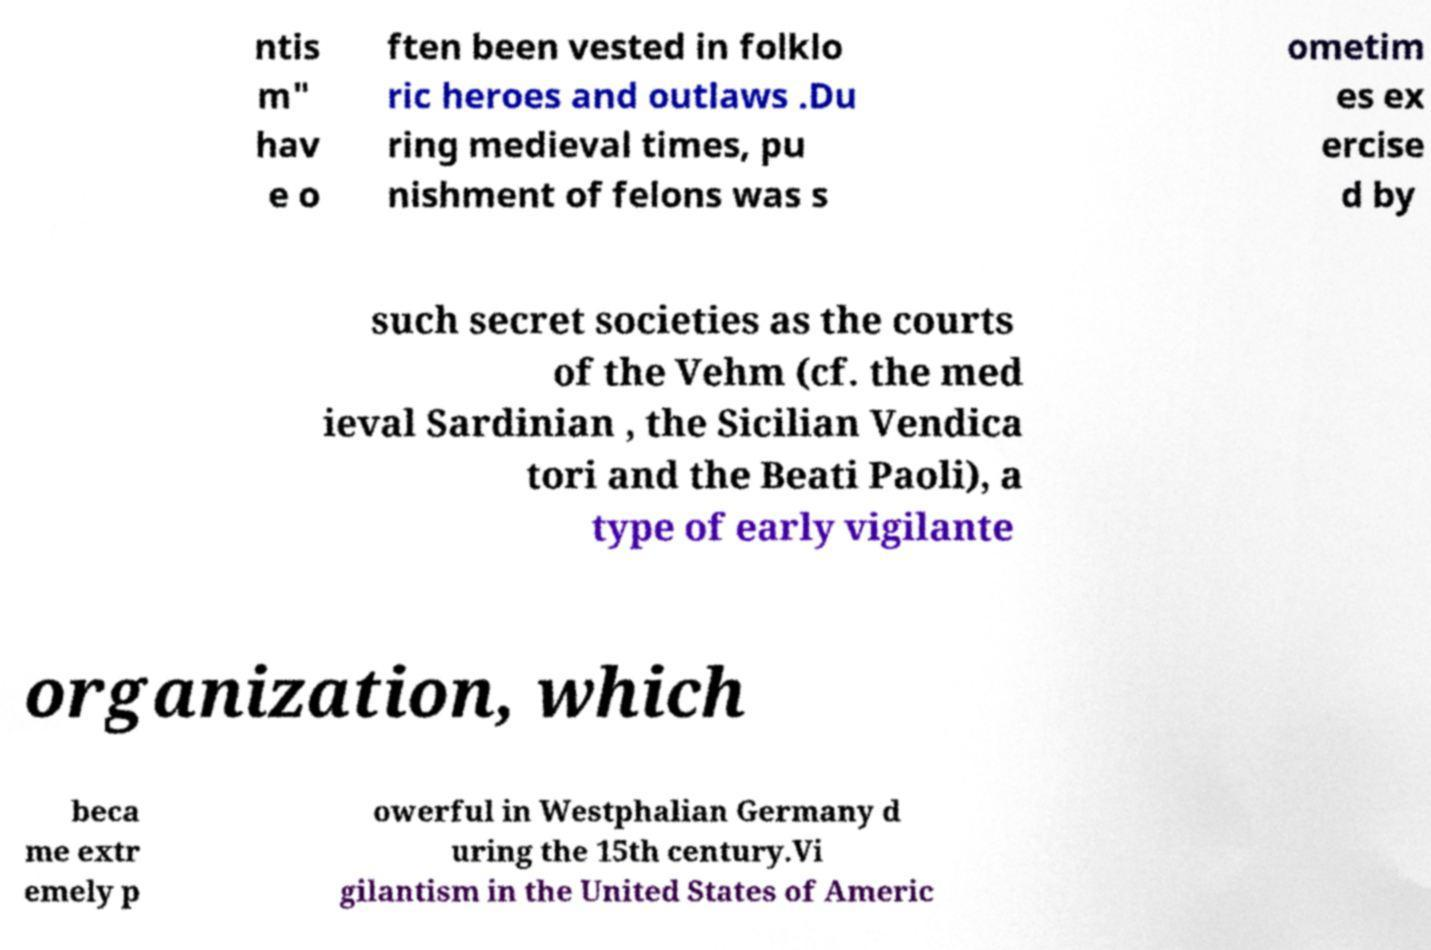For documentation purposes, I need the text within this image transcribed. Could you provide that? ntis m" hav e o ften been vested in folklo ric heroes and outlaws .Du ring medieval times, pu nishment of felons was s ometim es ex ercise d by such secret societies as the courts of the Vehm (cf. the med ieval Sardinian , the Sicilian Vendica tori and the Beati Paoli), a type of early vigilante organization, which beca me extr emely p owerful in Westphalian Germany d uring the 15th century.Vi gilantism in the United States of Americ 